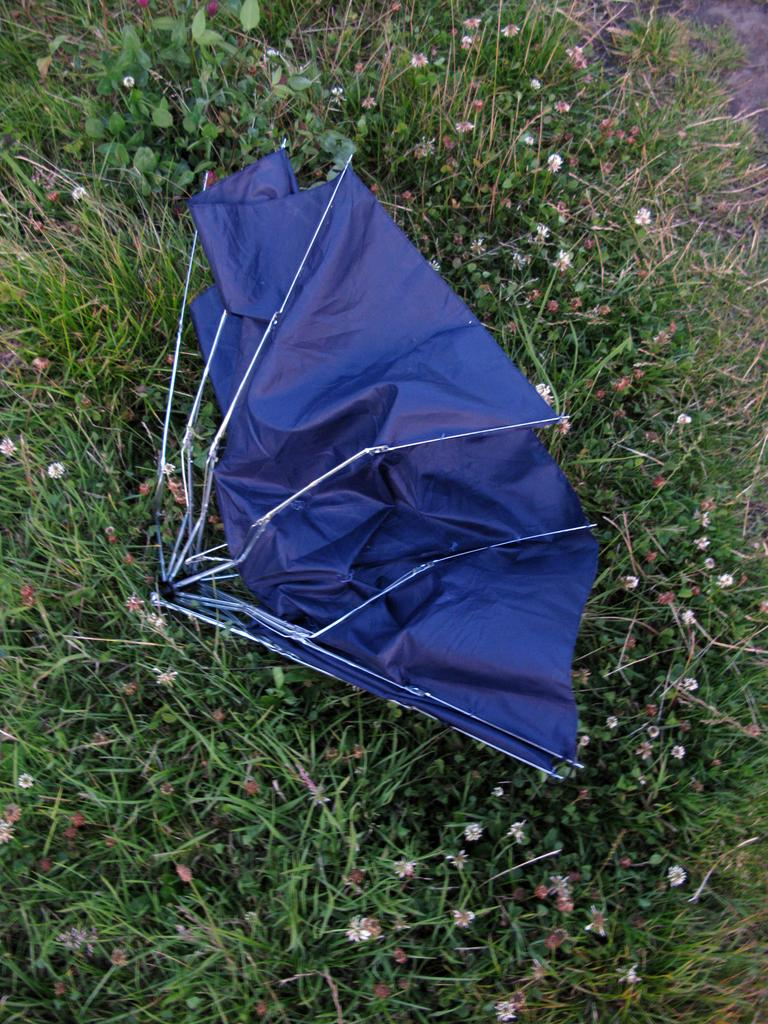What object is present in the image to provide shade or protection from the elements? There is an umbrella in the image. What type of vegetation can be seen in the image? There are plants with flowers in the image. What breed of dog can be seen playing with a boat in the image? There is no dog or boat present in the image; it only features an umbrella and plants with flowers. What scent is emitted by the plants in the image? The image does not provide information about the scent of the plants, only their visual appearance. 